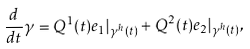<formula> <loc_0><loc_0><loc_500><loc_500>\frac { d } { d t } \gamma = Q ^ { 1 } ( t ) e _ { 1 } | _ { \gamma ^ { h } ( t ) } + Q ^ { 2 } ( t ) e _ { 2 } | _ { \gamma ^ { h } ( t ) } ,</formula> 